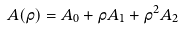<formula> <loc_0><loc_0><loc_500><loc_500>A ( \rho ) = A _ { 0 } + \rho A _ { 1 } + \rho ^ { 2 } A _ { 2 }</formula> 